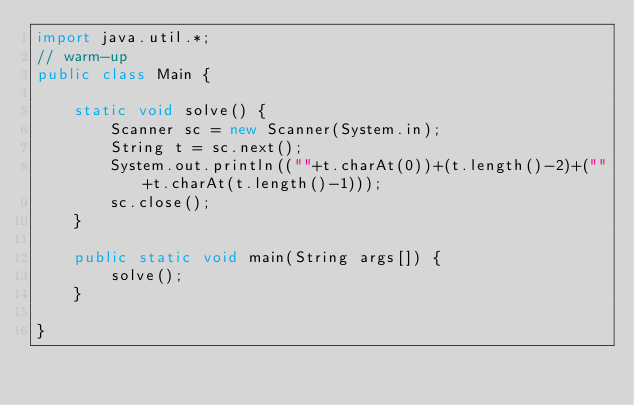Convert code to text. <code><loc_0><loc_0><loc_500><loc_500><_Java_>import java.util.*;
// warm-up
public class Main {

	static void solve() {
		Scanner sc = new Scanner(System.in);
		String t = sc.next();
		System.out.println((""+t.charAt(0))+(t.length()-2)+(""+t.charAt(t.length()-1)));
		sc.close();		
	}

	public static void main(String args[]) {
		solve();
	}

}</code> 